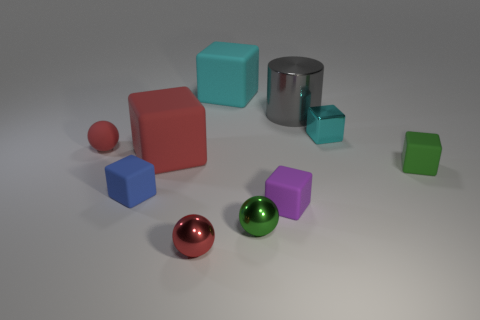The big object that is both behind the small cyan shiny thing and in front of the cyan rubber cube has what shape?
Offer a very short reply. Cylinder. Do the tiny rubber sphere and the large rubber cube that is in front of the small metal block have the same color?
Offer a very short reply. Yes. Is the size of the red ball to the right of the rubber ball the same as the small blue matte object?
Your answer should be very brief. Yes. There is a small cyan object that is the same shape as the big red object; what is it made of?
Your answer should be compact. Metal. Is the shape of the tiny purple thing the same as the big red rubber thing?
Your answer should be compact. Yes. What number of cyan metal blocks are left of the tiny rubber cube to the left of the small purple cube?
Your answer should be very brief. 0. The small red thing that is the same material as the purple block is what shape?
Provide a succinct answer. Sphere. What number of gray things are either large cylinders or small rubber spheres?
Make the answer very short. 1. There is a small green object on the right side of the green metallic sphere right of the blue rubber object; are there any blocks to the left of it?
Your response must be concise. Yes. Are there fewer cyan shiny objects than tiny yellow metal blocks?
Provide a succinct answer. No. 